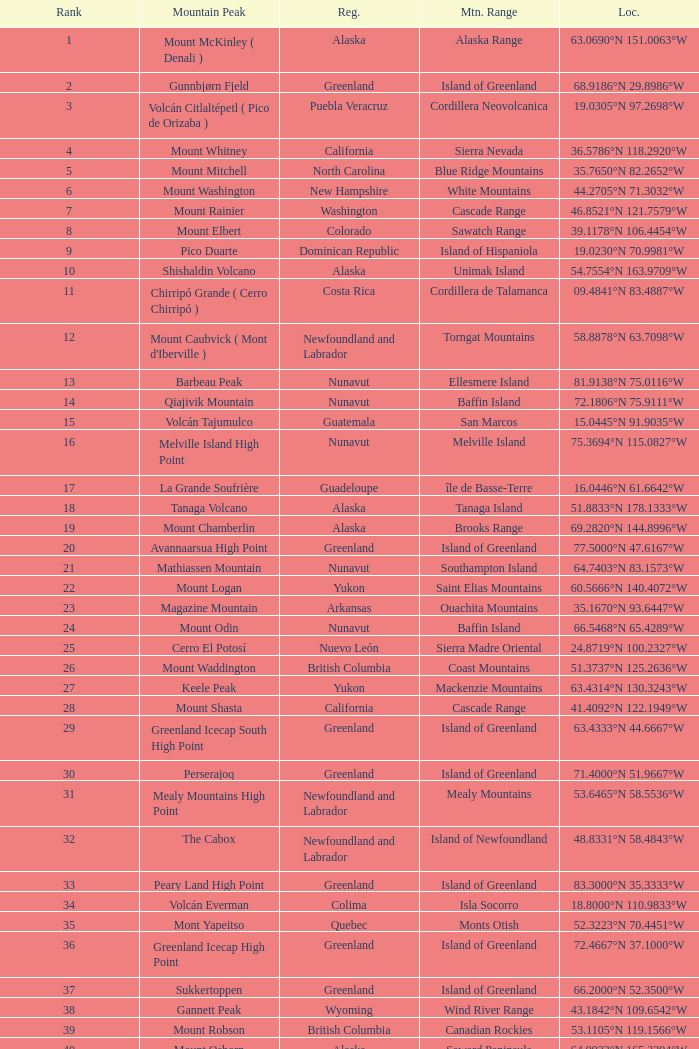Name the Region with a Mountain Peak of dillingham high point? Alaska. 